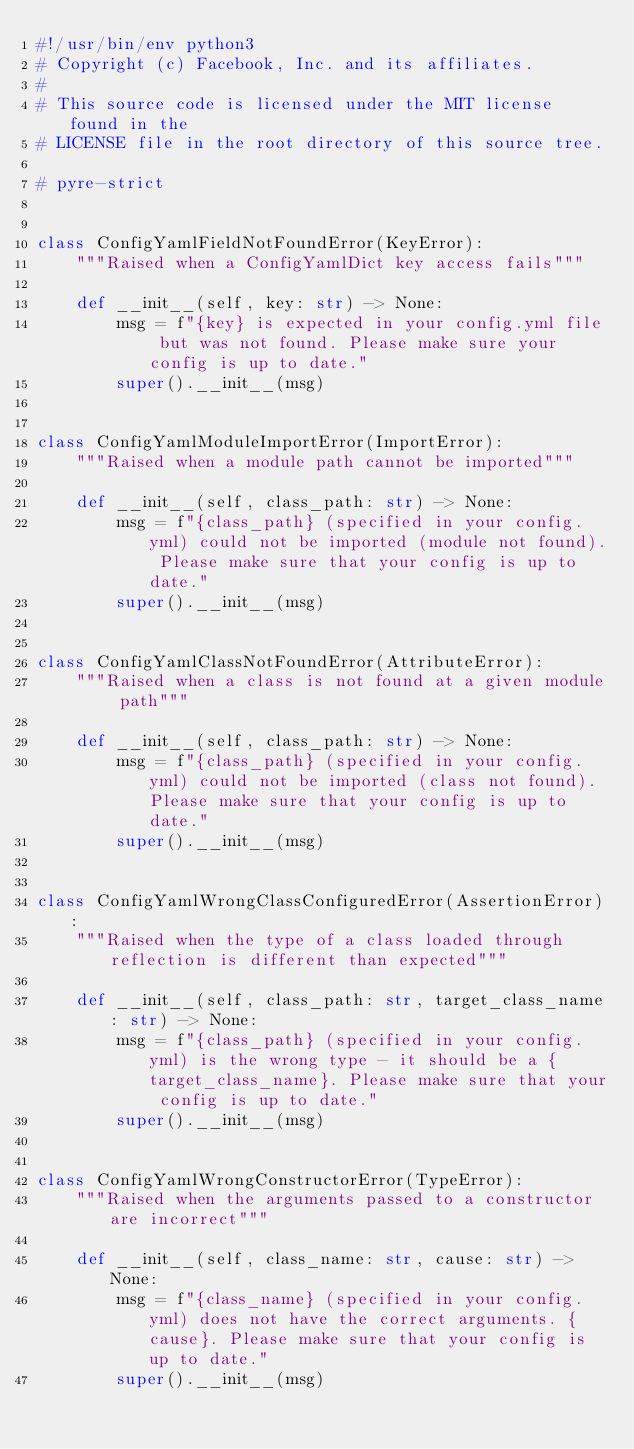<code> <loc_0><loc_0><loc_500><loc_500><_Python_>#!/usr/bin/env python3
# Copyright (c) Facebook, Inc. and its affiliates.
#
# This source code is licensed under the MIT license found in the
# LICENSE file in the root directory of this source tree.

# pyre-strict


class ConfigYamlFieldNotFoundError(KeyError):
    """Raised when a ConfigYamlDict key access fails"""

    def __init__(self, key: str) -> None:
        msg = f"{key} is expected in your config.yml file but was not found. Please make sure your config is up to date."
        super().__init__(msg)


class ConfigYamlModuleImportError(ImportError):
    """Raised when a module path cannot be imported"""

    def __init__(self, class_path: str) -> None:
        msg = f"{class_path} (specified in your config.yml) could not be imported (module not found). Please make sure that your config is up to date."
        super().__init__(msg)


class ConfigYamlClassNotFoundError(AttributeError):
    """Raised when a class is not found at a given module path"""

    def __init__(self, class_path: str) -> None:
        msg = f"{class_path} (specified in your config.yml) could not be imported (class not found). Please make sure that your config is up to date."
        super().__init__(msg)


class ConfigYamlWrongClassConfiguredError(AssertionError):
    """Raised when the type of a class loaded through reflection is different than expected"""

    def __init__(self, class_path: str, target_class_name: str) -> None:
        msg = f"{class_path} (specified in your config.yml) is the wrong type - it should be a {target_class_name}. Please make sure that your config is up to date."
        super().__init__(msg)


class ConfigYamlWrongConstructorError(TypeError):
    """Raised when the arguments passed to a constructor are incorrect"""

    def __init__(self, class_name: str, cause: str) -> None:
        msg = f"{class_name} (specified in your config.yml) does not have the correct arguments. {cause}. Please make sure that your config is up to date."
        super().__init__(msg)
</code> 